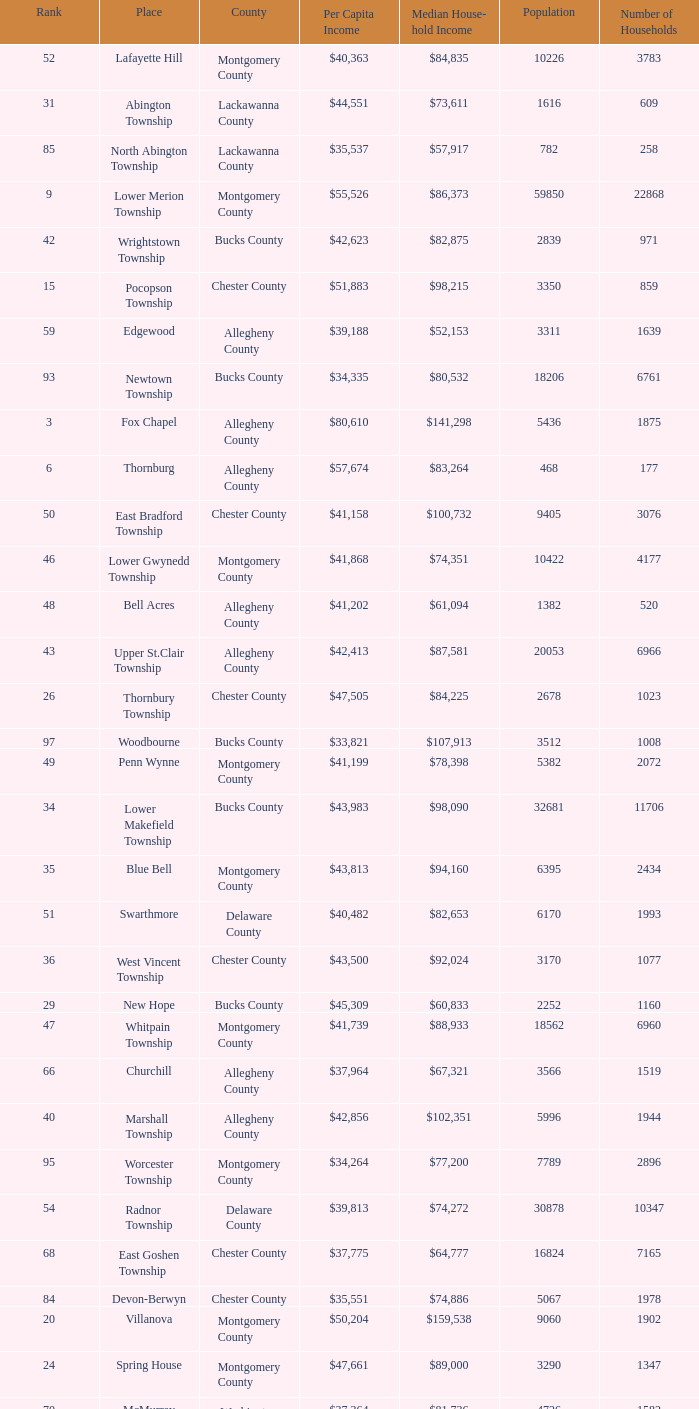Which place has a rank of 71? Wyomissing. 